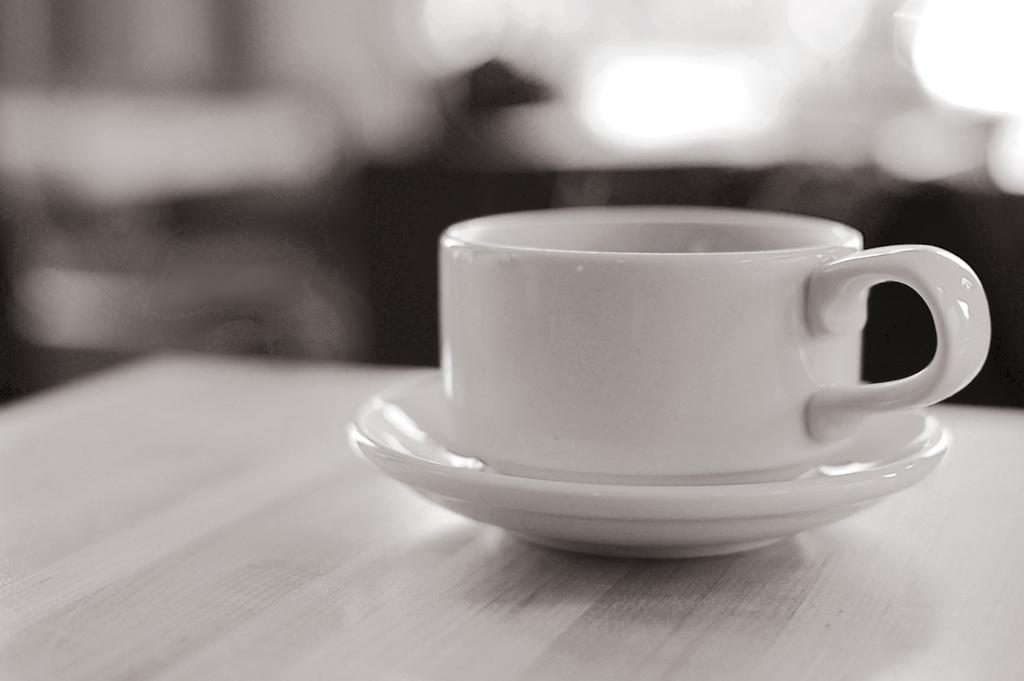What is present on the table in the image? There is a cup and a saucer on the table in the image. What is the relationship between the cup and the saucer in the image? Both the cup and saucer are on the table in the image. Can you see a mask being worn by the cup in the image? There is no mask present in the image, and the cup is not wearing anything. 